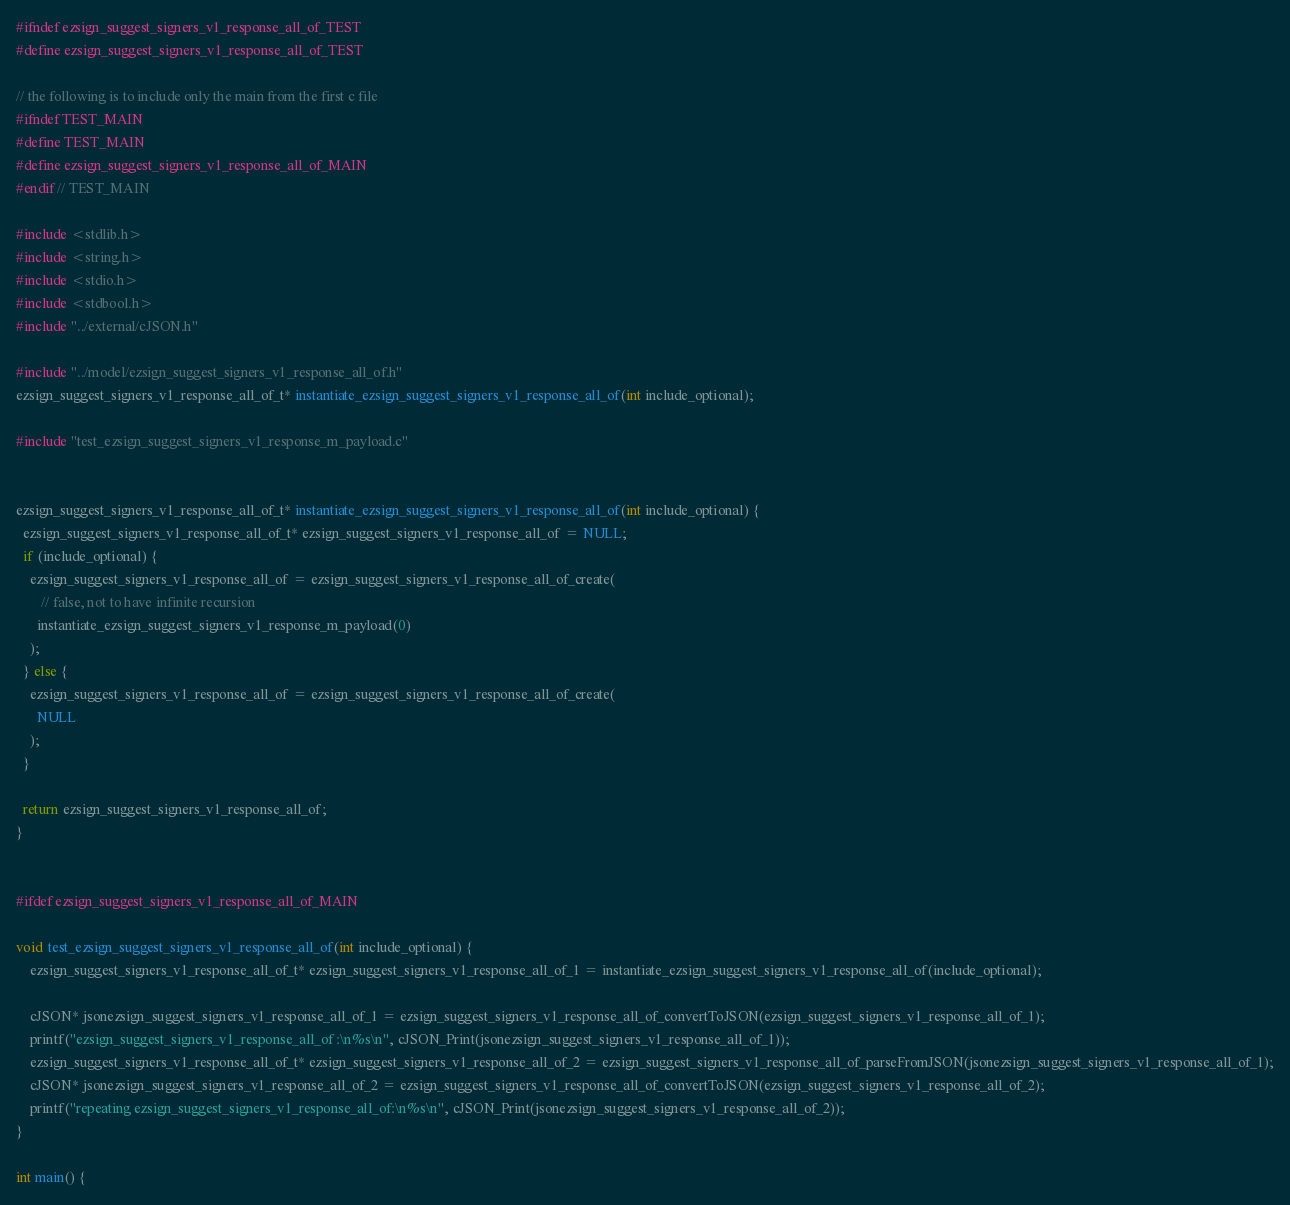Convert code to text. <code><loc_0><loc_0><loc_500><loc_500><_C_>#ifndef ezsign_suggest_signers_v1_response_all_of_TEST
#define ezsign_suggest_signers_v1_response_all_of_TEST

// the following is to include only the main from the first c file
#ifndef TEST_MAIN
#define TEST_MAIN
#define ezsign_suggest_signers_v1_response_all_of_MAIN
#endif // TEST_MAIN

#include <stdlib.h>
#include <string.h>
#include <stdio.h>
#include <stdbool.h>
#include "../external/cJSON.h"

#include "../model/ezsign_suggest_signers_v1_response_all_of.h"
ezsign_suggest_signers_v1_response_all_of_t* instantiate_ezsign_suggest_signers_v1_response_all_of(int include_optional);

#include "test_ezsign_suggest_signers_v1_response_m_payload.c"


ezsign_suggest_signers_v1_response_all_of_t* instantiate_ezsign_suggest_signers_v1_response_all_of(int include_optional) {
  ezsign_suggest_signers_v1_response_all_of_t* ezsign_suggest_signers_v1_response_all_of = NULL;
  if (include_optional) {
    ezsign_suggest_signers_v1_response_all_of = ezsign_suggest_signers_v1_response_all_of_create(
       // false, not to have infinite recursion
      instantiate_ezsign_suggest_signers_v1_response_m_payload(0)
    );
  } else {
    ezsign_suggest_signers_v1_response_all_of = ezsign_suggest_signers_v1_response_all_of_create(
      NULL
    );
  }

  return ezsign_suggest_signers_v1_response_all_of;
}


#ifdef ezsign_suggest_signers_v1_response_all_of_MAIN

void test_ezsign_suggest_signers_v1_response_all_of(int include_optional) {
    ezsign_suggest_signers_v1_response_all_of_t* ezsign_suggest_signers_v1_response_all_of_1 = instantiate_ezsign_suggest_signers_v1_response_all_of(include_optional);

	cJSON* jsonezsign_suggest_signers_v1_response_all_of_1 = ezsign_suggest_signers_v1_response_all_of_convertToJSON(ezsign_suggest_signers_v1_response_all_of_1);
	printf("ezsign_suggest_signers_v1_response_all_of :\n%s\n", cJSON_Print(jsonezsign_suggest_signers_v1_response_all_of_1));
	ezsign_suggest_signers_v1_response_all_of_t* ezsign_suggest_signers_v1_response_all_of_2 = ezsign_suggest_signers_v1_response_all_of_parseFromJSON(jsonezsign_suggest_signers_v1_response_all_of_1);
	cJSON* jsonezsign_suggest_signers_v1_response_all_of_2 = ezsign_suggest_signers_v1_response_all_of_convertToJSON(ezsign_suggest_signers_v1_response_all_of_2);
	printf("repeating ezsign_suggest_signers_v1_response_all_of:\n%s\n", cJSON_Print(jsonezsign_suggest_signers_v1_response_all_of_2));
}

int main() {</code> 